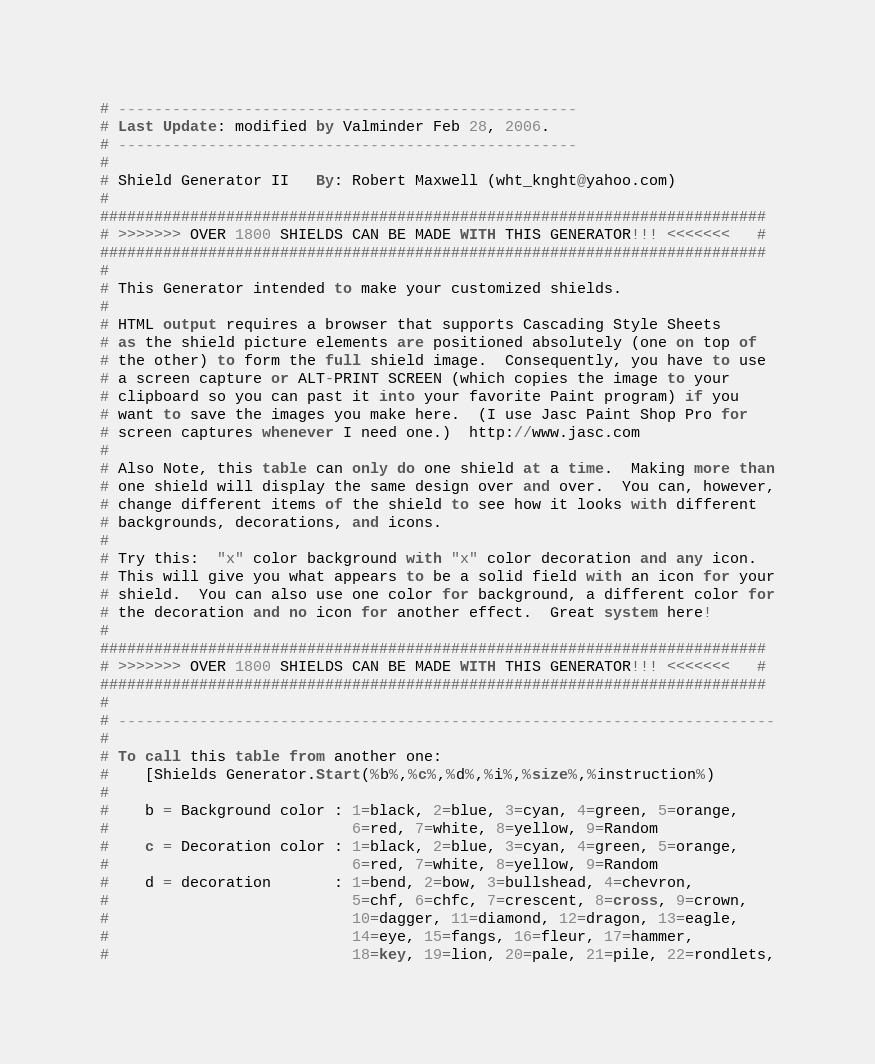<code> <loc_0><loc_0><loc_500><loc_500><_SQL_># ---------------------------------------------------
# Last Update: modified by Valminder Feb 28, 2006.
# ---------------------------------------------------
#
# Shield Generator II   By: Robert Maxwell (wht_knght@yahoo.com)
#
##########################################################################
# >>>>>>> OVER 1800 SHIELDS CAN BE MADE WITH THIS GENERATOR!!! <<<<<<<   #
##########################################################################
#
# This Generator intended to make your customized shields.
# 
# HTML output requires a browser that supports Cascading Style Sheets
# as the shield picture elements are positioned absolutely (one on top of
# the other) to form the full shield image.  Consequently, you have to use
# a screen capture or ALT-PRINT SCREEN (which copies the image to your
# clipboard so you can past it into your favorite Paint program) if you
# want to save the images you make here.  (I use Jasc Paint Shop Pro for
# screen captures whenever I need one.)  http://www.jasc.com
#
# Also Note, this table can only do one shield at a time.  Making more than
# one shield will display the same design over and over.  You can, however,
# change different items of the shield to see how it looks with different
# backgrounds, decorations, and icons.
#
# Try this:  "x" color background with "x" color decoration and any icon.
# This will give you what appears to be a solid field with an icon for your
# shield.  You can also use one color for background, a different color for
# the decoration and no icon for another effect.  Great system here!
#
##########################################################################
# >>>>>>> OVER 1800 SHIELDS CAN BE MADE WITH THIS GENERATOR!!! <<<<<<<   #
##########################################################################
#
# -------------------------------------------------------------------------
#
# To call this table from another one:
#    [Shields Generator.Start(%b%,%c%,%d%,%i%,%size%,%instruction%)
#
#    b = Background color : 1=black, 2=blue, 3=cyan, 4=green, 5=orange,
#                           6=red, 7=white, 8=yellow, 9=Random
#    c = Decoration color : 1=black, 2=blue, 3=cyan, 4=green, 5=orange,
#                           6=red, 7=white, 8=yellow, 9=Random
#    d = decoration       : 1=bend, 2=bow, 3=bullshead, 4=chevron, 
#                           5=chf, 6=chfc, 7=crescent, 8=cross, 9=crown,
#                           10=dagger, 11=diamond, 12=dragon, 13=eagle,
#                           14=eye, 15=fangs, 16=fleur, 17=hammer,
#                           18=key, 19=lion, 20=pale, 21=pile, 22=rondlets,</code> 